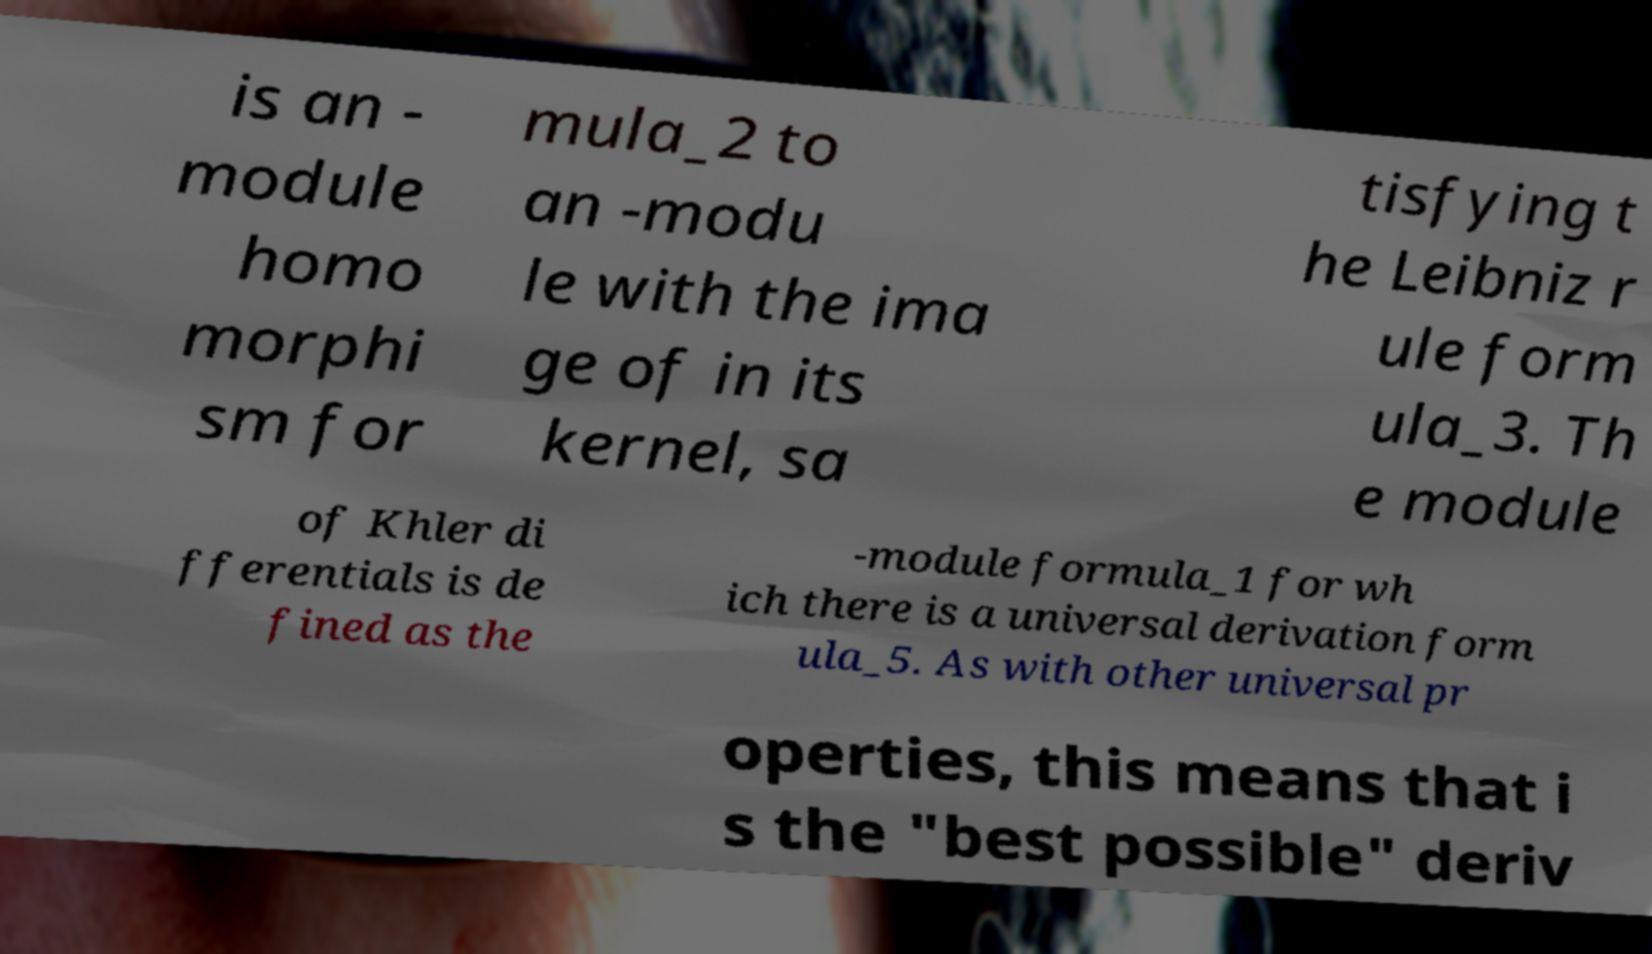I need the written content from this picture converted into text. Can you do that? is an - module homo morphi sm for mula_2 to an -modu le with the ima ge of in its kernel, sa tisfying t he Leibniz r ule form ula_3. Th e module of Khler di fferentials is de fined as the -module formula_1 for wh ich there is a universal derivation form ula_5. As with other universal pr operties, this means that i s the "best possible" deriv 